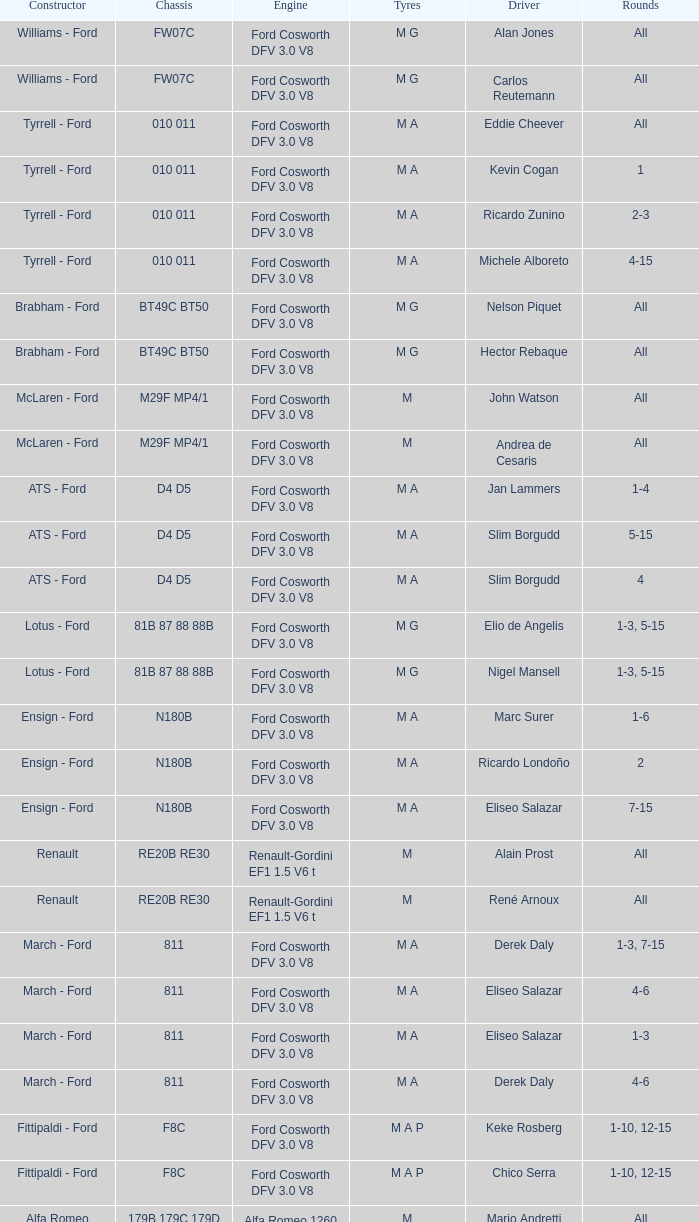Which manufacturer made the car featuring a tg181 chassis that derek warwick raced? Toleman - Hart. 